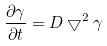Convert formula to latex. <formula><loc_0><loc_0><loc_500><loc_500>\frac { \partial \gamma } { \partial t } = D \bigtriangledown ^ { 2 } \gamma</formula> 